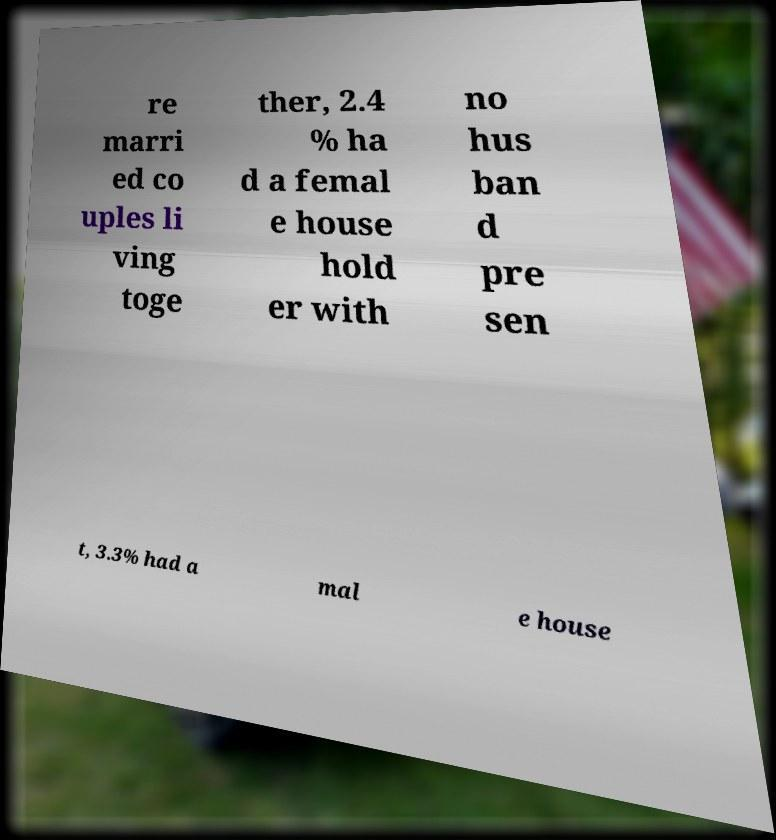Can you accurately transcribe the text from the provided image for me? re marri ed co uples li ving toge ther, 2.4 % ha d a femal e house hold er with no hus ban d pre sen t, 3.3% had a mal e house 